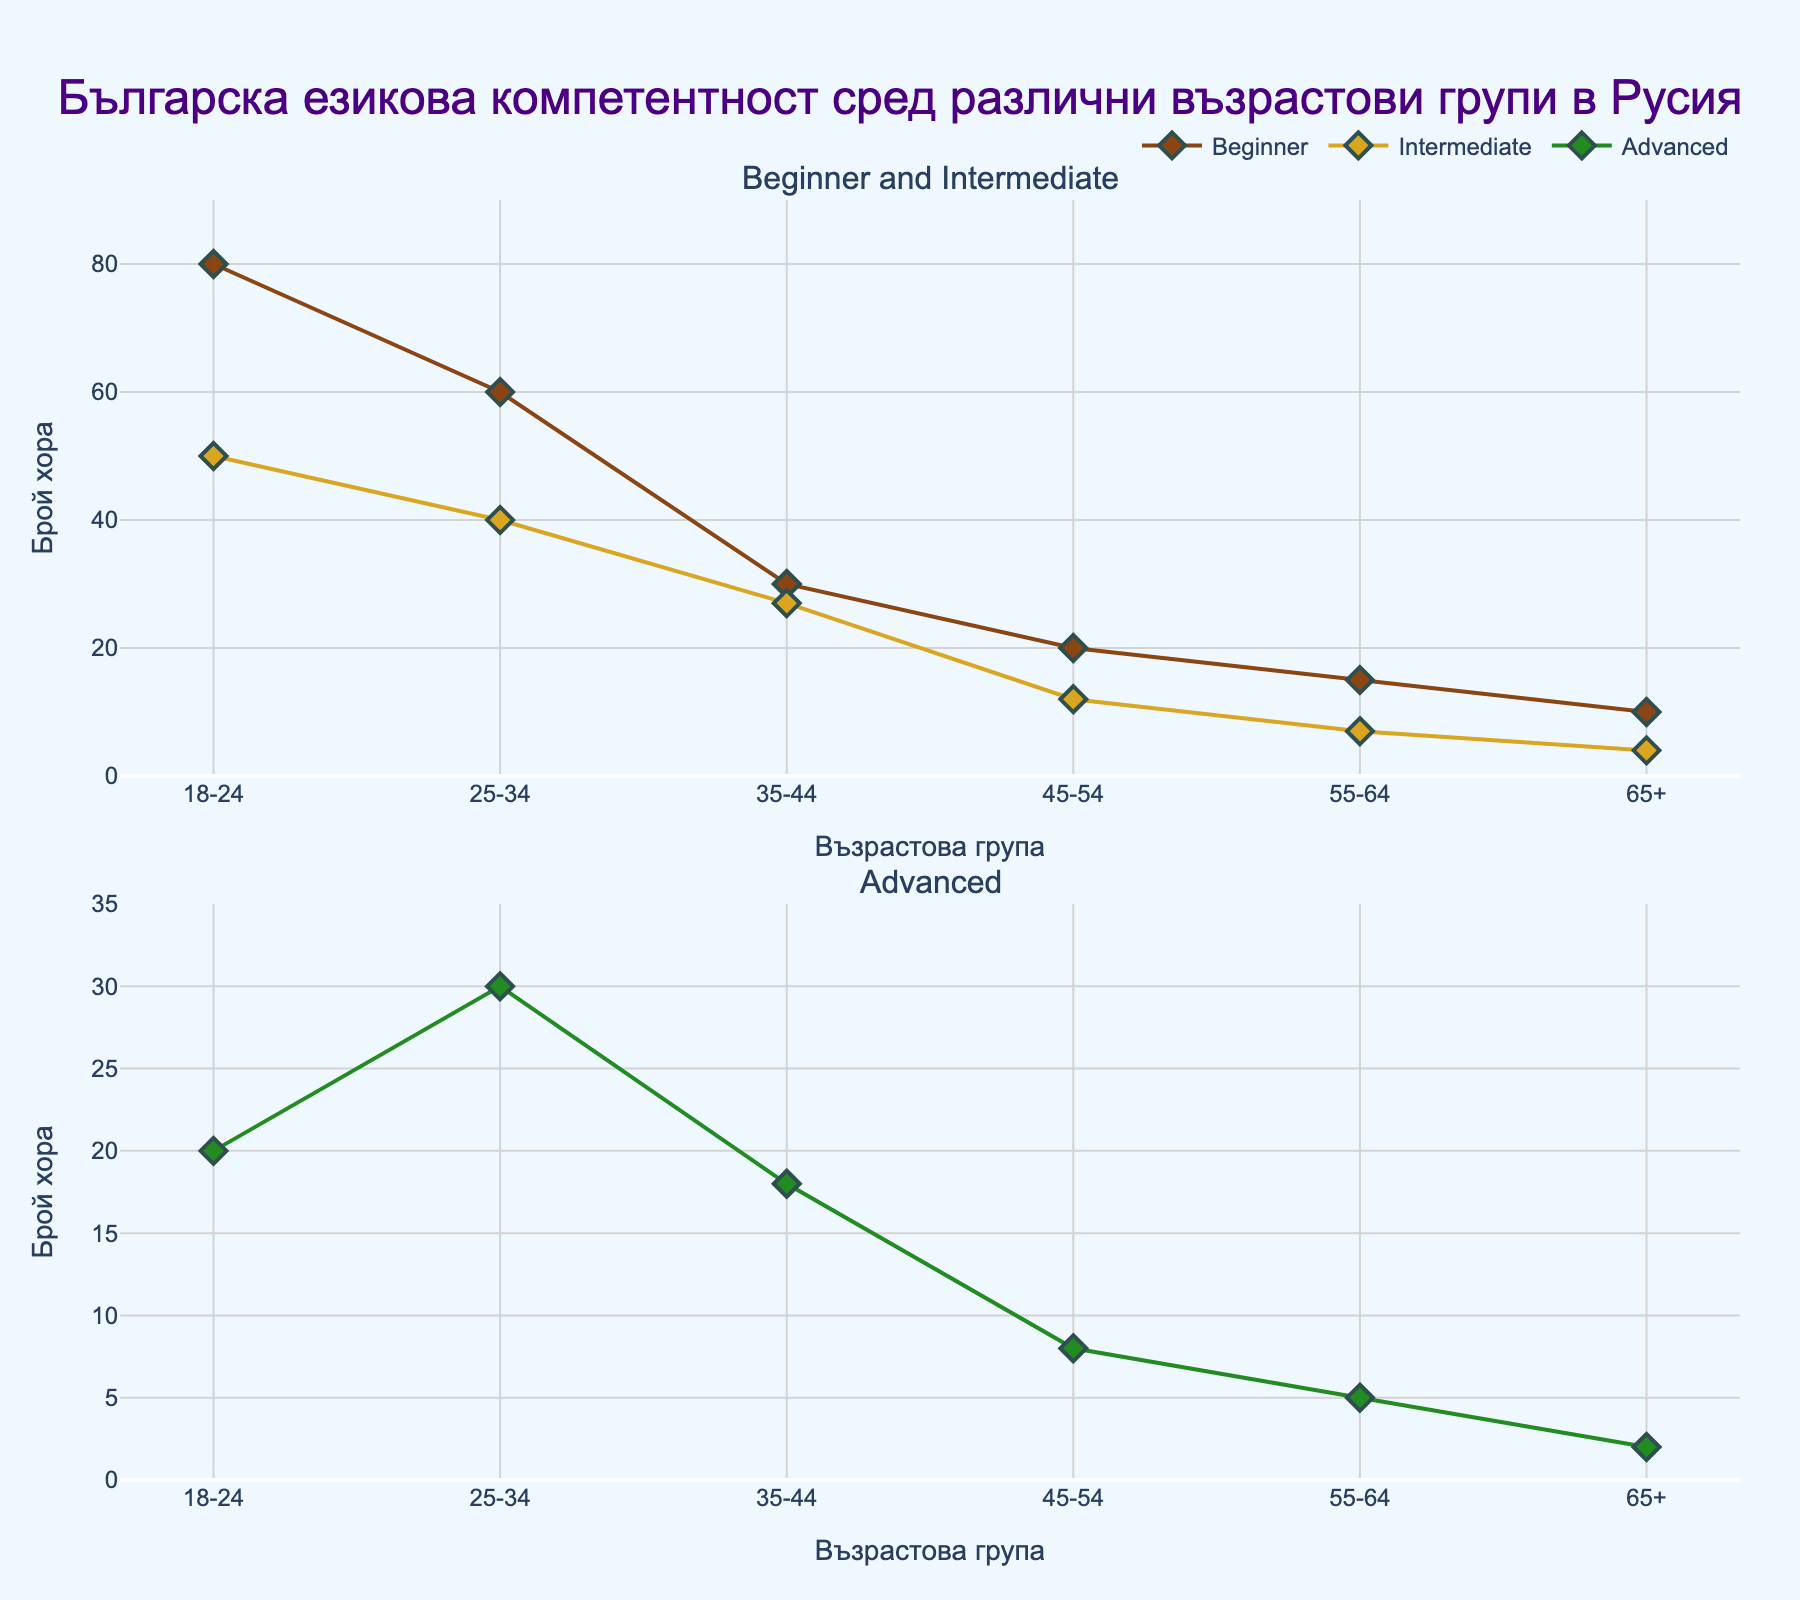Which age group has the highest number of individuals at the Beginner level? The scatter plot shows the number of individuals for each age group at different proficiency levels. The marker representing the Beginner proficiency for the 18-24 age group is positioned highest among Beginner markers.
Answer: 18-24 What's the pattern of Intermediate proficiency across age groups? Observing the Intermediate proficiency markers spanning across age groups, the number of individuals decreases consistently as age increases.
Answer: Decreasing How does the number of individuals with Advanced proficiency in the 25-34 age group compare to those in the 18-24 age group? Comparing the Advanced proficiency markers, the value for the 25-34 age group is 30, while for the 18-24 age group it is 20.
Answer: 25-34 is higher What is the combined number of individuals with Intermediate proficiency in the 35-44 and 45-54 age groups? Analyzing the two Intermediate proficiency markers for the 35-44 and 45-54 age groups, the values are 27 and 12, respectively. Adding these gives 27 + 12 = 39.
Answer: 39 What can be inferred about Bulgarian language proficiency levels among older age groups (55-64 and 65+)? Observing the number of individuals in older age groups, proficiency levels decrease significantly, indicating lower interest or opportunity for Bulgarian language learning among older individuals.
Answer: Decreasing significantly Which age group has the lowest number of individuals at the Advanced proficiency level? Inspecting the markers for the Advanced level across all age groups, the 65+ age group has the lowest with a value of 2.
Answer: 65+ Compare the trend of Beginner proficiency against Advanced proficiency levels across age groups. Beginner proficiency generally shows a downward trend as age increases. Advanced proficiency also decreases with age but starts from a lower base compared to Beginner. Both levels decrease with age, but Beginner has higher initial values.
Answer: Both decrease, Beginner higher initially What is the difference in the number of individuals with Advanced proficiency between the 45-54 and 55-64 age groups? Looking at the Advanced proficiency markers, the 45-54 age group has 8 individuals and the 55-64 age group has 5. The difference is 8 - 5 = 3.
Answer: 3 